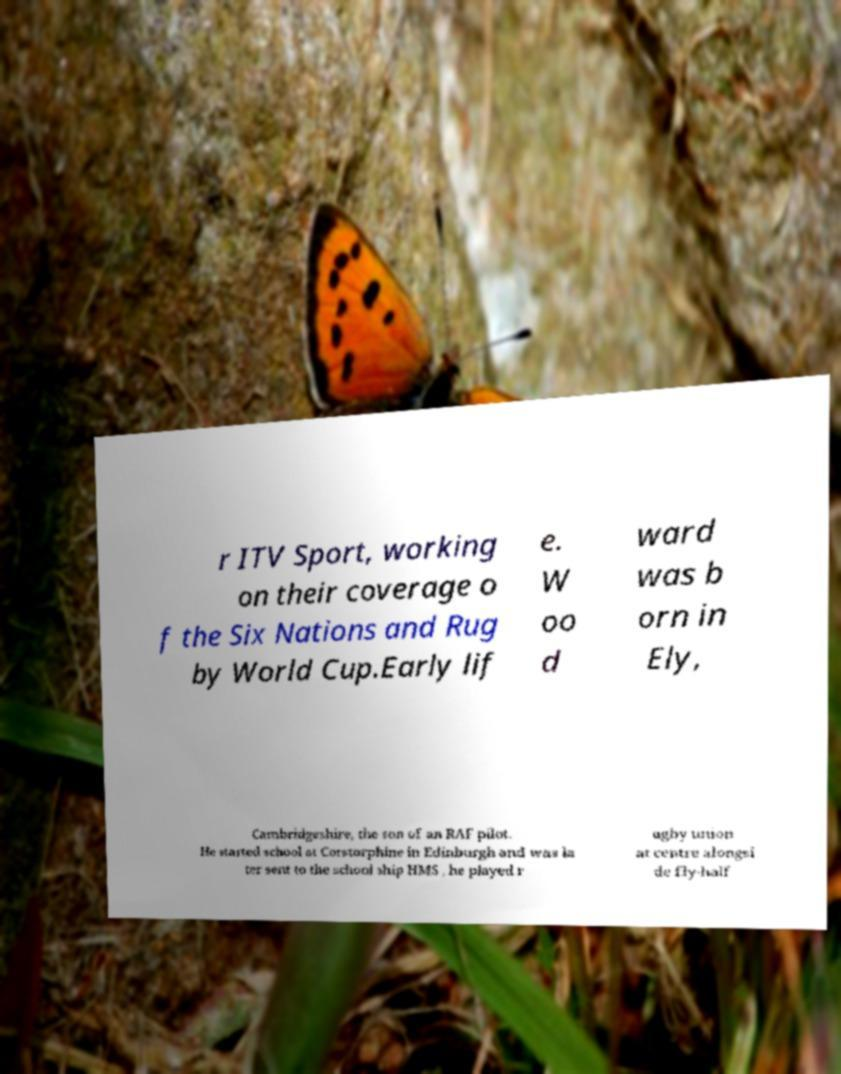I need the written content from this picture converted into text. Can you do that? r ITV Sport, working on their coverage o f the Six Nations and Rug by World Cup.Early lif e. W oo d ward was b orn in Ely, Cambridgeshire, the son of an RAF pilot. He started school at Corstorphine in Edinburgh and was la ter sent to the school ship HMS , he played r ugby union at centre alongsi de fly-half 